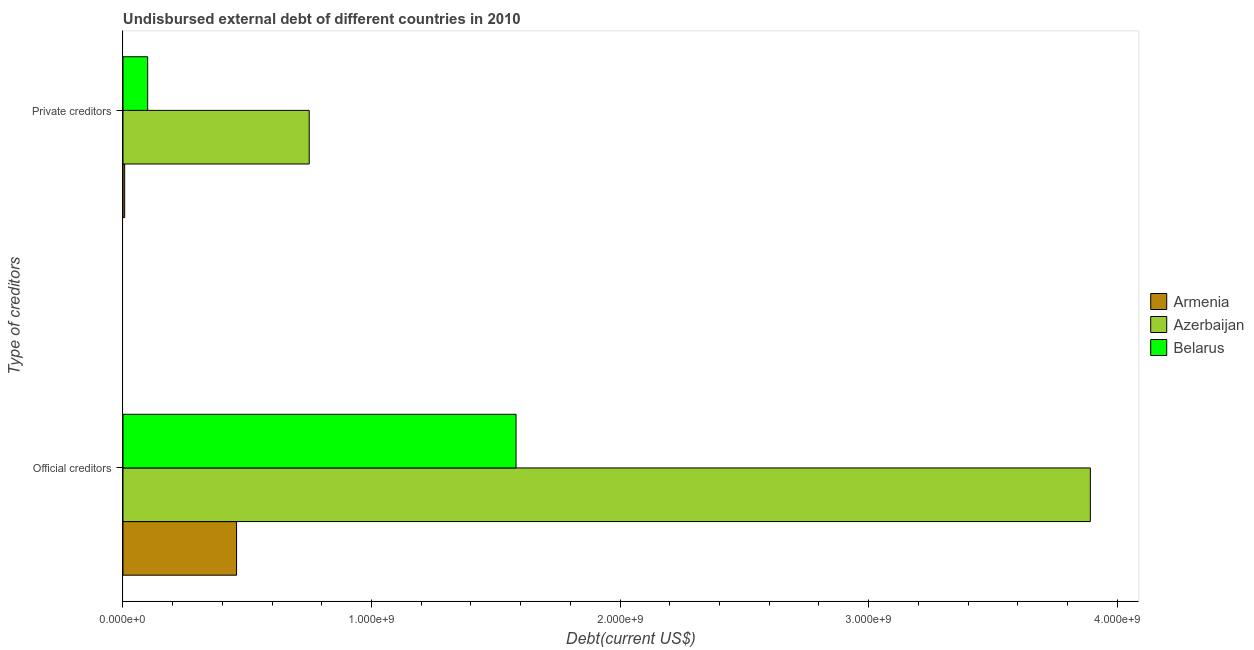How many different coloured bars are there?
Offer a terse response. 3. How many groups of bars are there?
Provide a short and direct response. 2. Are the number of bars per tick equal to the number of legend labels?
Your response must be concise. Yes. Are the number of bars on each tick of the Y-axis equal?
Offer a very short reply. Yes. How many bars are there on the 2nd tick from the top?
Ensure brevity in your answer.  3. What is the label of the 1st group of bars from the top?
Your answer should be very brief. Private creditors. What is the undisbursed external debt of official creditors in Belarus?
Provide a short and direct response. 1.58e+09. Across all countries, what is the maximum undisbursed external debt of private creditors?
Your answer should be very brief. 7.49e+08. Across all countries, what is the minimum undisbursed external debt of private creditors?
Offer a terse response. 6.79e+06. In which country was the undisbursed external debt of official creditors maximum?
Keep it short and to the point. Azerbaijan. In which country was the undisbursed external debt of official creditors minimum?
Your answer should be very brief. Armenia. What is the total undisbursed external debt of official creditors in the graph?
Offer a terse response. 5.93e+09. What is the difference between the undisbursed external debt of private creditors in Azerbaijan and that in Belarus?
Offer a very short reply. 6.50e+08. What is the difference between the undisbursed external debt of official creditors in Belarus and the undisbursed external debt of private creditors in Armenia?
Your answer should be compact. 1.57e+09. What is the average undisbursed external debt of official creditors per country?
Keep it short and to the point. 1.98e+09. What is the difference between the undisbursed external debt of official creditors and undisbursed external debt of private creditors in Azerbaijan?
Provide a short and direct response. 3.14e+09. What is the ratio of the undisbursed external debt of private creditors in Azerbaijan to that in Armenia?
Your response must be concise. 110.37. Is the undisbursed external debt of official creditors in Belarus less than that in Azerbaijan?
Your answer should be very brief. Yes. What does the 3rd bar from the top in Private creditors represents?
Give a very brief answer. Armenia. What does the 2nd bar from the bottom in Official creditors represents?
Give a very brief answer. Azerbaijan. How many bars are there?
Provide a short and direct response. 6. How many countries are there in the graph?
Keep it short and to the point. 3. What is the difference between two consecutive major ticks on the X-axis?
Ensure brevity in your answer.  1.00e+09. Are the values on the major ticks of X-axis written in scientific E-notation?
Offer a terse response. Yes. Does the graph contain any zero values?
Offer a very short reply. No. Where does the legend appear in the graph?
Your response must be concise. Center right. How are the legend labels stacked?
Keep it short and to the point. Vertical. What is the title of the graph?
Make the answer very short. Undisbursed external debt of different countries in 2010. What is the label or title of the X-axis?
Ensure brevity in your answer.  Debt(current US$). What is the label or title of the Y-axis?
Make the answer very short. Type of creditors. What is the Debt(current US$) of Armenia in Official creditors?
Make the answer very short. 4.57e+08. What is the Debt(current US$) of Azerbaijan in Official creditors?
Provide a short and direct response. 3.89e+09. What is the Debt(current US$) in Belarus in Official creditors?
Keep it short and to the point. 1.58e+09. What is the Debt(current US$) in Armenia in Private creditors?
Keep it short and to the point. 6.79e+06. What is the Debt(current US$) in Azerbaijan in Private creditors?
Offer a terse response. 7.49e+08. What is the Debt(current US$) of Belarus in Private creditors?
Provide a short and direct response. 9.93e+07. Across all Type of creditors, what is the maximum Debt(current US$) of Armenia?
Give a very brief answer. 4.57e+08. Across all Type of creditors, what is the maximum Debt(current US$) of Azerbaijan?
Ensure brevity in your answer.  3.89e+09. Across all Type of creditors, what is the maximum Debt(current US$) in Belarus?
Offer a terse response. 1.58e+09. Across all Type of creditors, what is the minimum Debt(current US$) in Armenia?
Keep it short and to the point. 6.79e+06. Across all Type of creditors, what is the minimum Debt(current US$) in Azerbaijan?
Ensure brevity in your answer.  7.49e+08. Across all Type of creditors, what is the minimum Debt(current US$) in Belarus?
Offer a terse response. 9.93e+07. What is the total Debt(current US$) in Armenia in the graph?
Provide a short and direct response. 4.64e+08. What is the total Debt(current US$) of Azerbaijan in the graph?
Offer a terse response. 4.64e+09. What is the total Debt(current US$) of Belarus in the graph?
Offer a terse response. 1.68e+09. What is the difference between the Debt(current US$) of Armenia in Official creditors and that in Private creditors?
Keep it short and to the point. 4.50e+08. What is the difference between the Debt(current US$) of Azerbaijan in Official creditors and that in Private creditors?
Keep it short and to the point. 3.14e+09. What is the difference between the Debt(current US$) in Belarus in Official creditors and that in Private creditors?
Your response must be concise. 1.48e+09. What is the difference between the Debt(current US$) of Armenia in Official creditors and the Debt(current US$) of Azerbaijan in Private creditors?
Keep it short and to the point. -2.92e+08. What is the difference between the Debt(current US$) in Armenia in Official creditors and the Debt(current US$) in Belarus in Private creditors?
Ensure brevity in your answer.  3.58e+08. What is the difference between the Debt(current US$) in Azerbaijan in Official creditors and the Debt(current US$) in Belarus in Private creditors?
Ensure brevity in your answer.  3.79e+09. What is the average Debt(current US$) of Armenia per Type of creditors?
Ensure brevity in your answer.  2.32e+08. What is the average Debt(current US$) in Azerbaijan per Type of creditors?
Offer a terse response. 2.32e+09. What is the average Debt(current US$) in Belarus per Type of creditors?
Provide a succinct answer. 8.40e+08. What is the difference between the Debt(current US$) in Armenia and Debt(current US$) in Azerbaijan in Official creditors?
Ensure brevity in your answer.  -3.43e+09. What is the difference between the Debt(current US$) of Armenia and Debt(current US$) of Belarus in Official creditors?
Offer a very short reply. -1.12e+09. What is the difference between the Debt(current US$) of Azerbaijan and Debt(current US$) of Belarus in Official creditors?
Your response must be concise. 2.31e+09. What is the difference between the Debt(current US$) of Armenia and Debt(current US$) of Azerbaijan in Private creditors?
Make the answer very short. -7.43e+08. What is the difference between the Debt(current US$) of Armenia and Debt(current US$) of Belarus in Private creditors?
Keep it short and to the point. -9.25e+07. What is the difference between the Debt(current US$) in Azerbaijan and Debt(current US$) in Belarus in Private creditors?
Provide a short and direct response. 6.50e+08. What is the ratio of the Debt(current US$) of Armenia in Official creditors to that in Private creditors?
Your answer should be very brief. 67.31. What is the ratio of the Debt(current US$) in Azerbaijan in Official creditors to that in Private creditors?
Your answer should be very brief. 5.19. What is the ratio of the Debt(current US$) of Belarus in Official creditors to that in Private creditors?
Provide a succinct answer. 15.92. What is the difference between the highest and the second highest Debt(current US$) in Armenia?
Provide a succinct answer. 4.50e+08. What is the difference between the highest and the second highest Debt(current US$) of Azerbaijan?
Your response must be concise. 3.14e+09. What is the difference between the highest and the second highest Debt(current US$) of Belarus?
Your answer should be very brief. 1.48e+09. What is the difference between the highest and the lowest Debt(current US$) of Armenia?
Your answer should be compact. 4.50e+08. What is the difference between the highest and the lowest Debt(current US$) of Azerbaijan?
Offer a terse response. 3.14e+09. What is the difference between the highest and the lowest Debt(current US$) in Belarus?
Ensure brevity in your answer.  1.48e+09. 